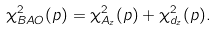Convert formula to latex. <formula><loc_0><loc_0><loc_500><loc_500>\chi _ { B A O } ^ { 2 } ( p ) = \chi _ { A _ { z } } ^ { 2 } ( p ) + \chi _ { d _ { z } } ^ { 2 } ( p ) .</formula> 